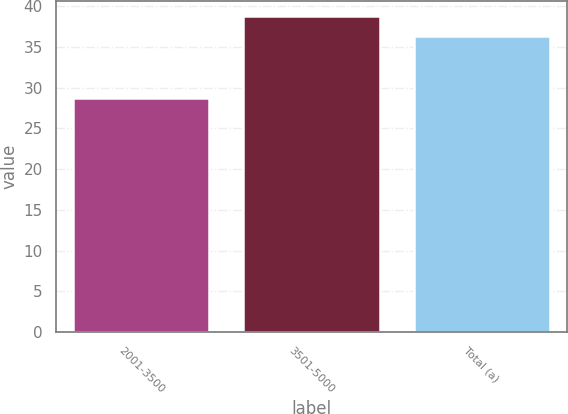<chart> <loc_0><loc_0><loc_500><loc_500><bar_chart><fcel>2001-3500<fcel>3501-5000<fcel>Total (a)<nl><fcel>28.79<fcel>38.76<fcel>36.33<nl></chart> 